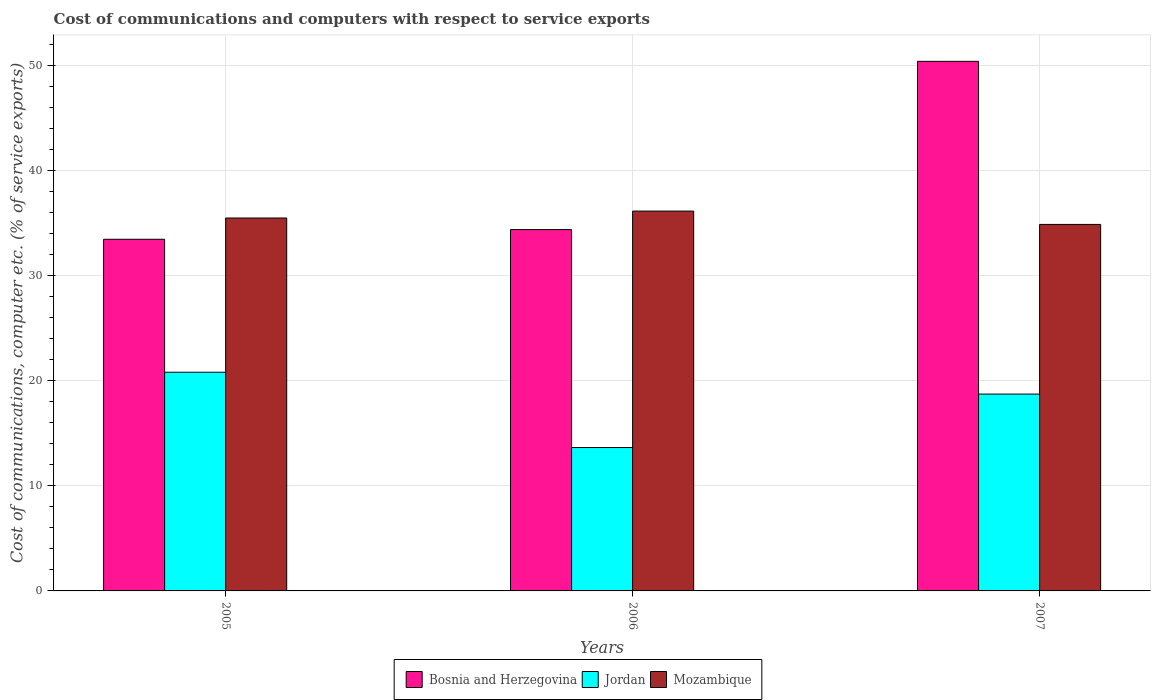How many different coloured bars are there?
Provide a succinct answer. 3. Are the number of bars per tick equal to the number of legend labels?
Provide a succinct answer. Yes. What is the label of the 2nd group of bars from the left?
Your response must be concise. 2006. What is the cost of communications and computers in Bosnia and Herzegovina in 2007?
Offer a very short reply. 50.39. Across all years, what is the maximum cost of communications and computers in Bosnia and Herzegovina?
Offer a very short reply. 50.39. Across all years, what is the minimum cost of communications and computers in Jordan?
Offer a terse response. 13.64. In which year was the cost of communications and computers in Jordan maximum?
Give a very brief answer. 2005. What is the total cost of communications and computers in Mozambique in the graph?
Offer a terse response. 106.5. What is the difference between the cost of communications and computers in Jordan in 2006 and that in 2007?
Keep it short and to the point. -5.09. What is the difference between the cost of communications and computers in Mozambique in 2007 and the cost of communications and computers in Bosnia and Herzegovina in 2006?
Your response must be concise. 0.49. What is the average cost of communications and computers in Bosnia and Herzegovina per year?
Your answer should be very brief. 39.41. In the year 2005, what is the difference between the cost of communications and computers in Mozambique and cost of communications and computers in Jordan?
Make the answer very short. 14.68. What is the ratio of the cost of communications and computers in Mozambique in 2005 to that in 2007?
Your answer should be compact. 1.02. Is the difference between the cost of communications and computers in Mozambique in 2005 and 2006 greater than the difference between the cost of communications and computers in Jordan in 2005 and 2006?
Your answer should be very brief. No. What is the difference between the highest and the second highest cost of communications and computers in Bosnia and Herzegovina?
Provide a short and direct response. 16.01. What is the difference between the highest and the lowest cost of communications and computers in Bosnia and Herzegovina?
Make the answer very short. 16.93. In how many years, is the cost of communications and computers in Mozambique greater than the average cost of communications and computers in Mozambique taken over all years?
Offer a terse response. 1. What does the 3rd bar from the left in 2006 represents?
Your answer should be compact. Mozambique. What does the 3rd bar from the right in 2006 represents?
Your answer should be compact. Bosnia and Herzegovina. Are all the bars in the graph horizontal?
Your answer should be very brief. No. How many years are there in the graph?
Your answer should be compact. 3. Are the values on the major ticks of Y-axis written in scientific E-notation?
Your answer should be compact. No. Does the graph contain any zero values?
Offer a very short reply. No. Does the graph contain grids?
Make the answer very short. Yes. How many legend labels are there?
Provide a succinct answer. 3. What is the title of the graph?
Your response must be concise. Cost of communications and computers with respect to service exports. Does "Namibia" appear as one of the legend labels in the graph?
Offer a very short reply. No. What is the label or title of the Y-axis?
Keep it short and to the point. Cost of communications, computer etc. (% of service exports). What is the Cost of communications, computer etc. (% of service exports) of Bosnia and Herzegovina in 2005?
Ensure brevity in your answer.  33.46. What is the Cost of communications, computer etc. (% of service exports) in Jordan in 2005?
Your response must be concise. 20.81. What is the Cost of communications, computer etc. (% of service exports) in Mozambique in 2005?
Keep it short and to the point. 35.48. What is the Cost of communications, computer etc. (% of service exports) of Bosnia and Herzegovina in 2006?
Your answer should be compact. 34.38. What is the Cost of communications, computer etc. (% of service exports) in Jordan in 2006?
Make the answer very short. 13.64. What is the Cost of communications, computer etc. (% of service exports) in Mozambique in 2006?
Your response must be concise. 36.14. What is the Cost of communications, computer etc. (% of service exports) in Bosnia and Herzegovina in 2007?
Provide a succinct answer. 50.39. What is the Cost of communications, computer etc. (% of service exports) in Jordan in 2007?
Offer a terse response. 18.73. What is the Cost of communications, computer etc. (% of service exports) of Mozambique in 2007?
Offer a very short reply. 34.87. Across all years, what is the maximum Cost of communications, computer etc. (% of service exports) of Bosnia and Herzegovina?
Provide a succinct answer. 50.39. Across all years, what is the maximum Cost of communications, computer etc. (% of service exports) in Jordan?
Your answer should be compact. 20.81. Across all years, what is the maximum Cost of communications, computer etc. (% of service exports) of Mozambique?
Keep it short and to the point. 36.14. Across all years, what is the minimum Cost of communications, computer etc. (% of service exports) in Bosnia and Herzegovina?
Ensure brevity in your answer.  33.46. Across all years, what is the minimum Cost of communications, computer etc. (% of service exports) in Jordan?
Ensure brevity in your answer.  13.64. Across all years, what is the minimum Cost of communications, computer etc. (% of service exports) in Mozambique?
Provide a short and direct response. 34.87. What is the total Cost of communications, computer etc. (% of service exports) in Bosnia and Herzegovina in the graph?
Provide a succinct answer. 118.23. What is the total Cost of communications, computer etc. (% of service exports) in Jordan in the graph?
Provide a short and direct response. 53.18. What is the total Cost of communications, computer etc. (% of service exports) in Mozambique in the graph?
Your answer should be compact. 106.5. What is the difference between the Cost of communications, computer etc. (% of service exports) of Bosnia and Herzegovina in 2005 and that in 2006?
Make the answer very short. -0.92. What is the difference between the Cost of communications, computer etc. (% of service exports) of Jordan in 2005 and that in 2006?
Keep it short and to the point. 7.16. What is the difference between the Cost of communications, computer etc. (% of service exports) in Mozambique in 2005 and that in 2006?
Provide a short and direct response. -0.66. What is the difference between the Cost of communications, computer etc. (% of service exports) of Bosnia and Herzegovina in 2005 and that in 2007?
Provide a succinct answer. -16.93. What is the difference between the Cost of communications, computer etc. (% of service exports) in Jordan in 2005 and that in 2007?
Provide a succinct answer. 2.08. What is the difference between the Cost of communications, computer etc. (% of service exports) of Mozambique in 2005 and that in 2007?
Keep it short and to the point. 0.61. What is the difference between the Cost of communications, computer etc. (% of service exports) in Bosnia and Herzegovina in 2006 and that in 2007?
Offer a terse response. -16.01. What is the difference between the Cost of communications, computer etc. (% of service exports) of Jordan in 2006 and that in 2007?
Keep it short and to the point. -5.09. What is the difference between the Cost of communications, computer etc. (% of service exports) of Mozambique in 2006 and that in 2007?
Keep it short and to the point. 1.27. What is the difference between the Cost of communications, computer etc. (% of service exports) of Bosnia and Herzegovina in 2005 and the Cost of communications, computer etc. (% of service exports) of Jordan in 2006?
Provide a succinct answer. 19.82. What is the difference between the Cost of communications, computer etc. (% of service exports) in Bosnia and Herzegovina in 2005 and the Cost of communications, computer etc. (% of service exports) in Mozambique in 2006?
Keep it short and to the point. -2.68. What is the difference between the Cost of communications, computer etc. (% of service exports) in Jordan in 2005 and the Cost of communications, computer etc. (% of service exports) in Mozambique in 2006?
Make the answer very short. -15.34. What is the difference between the Cost of communications, computer etc. (% of service exports) of Bosnia and Herzegovina in 2005 and the Cost of communications, computer etc. (% of service exports) of Jordan in 2007?
Keep it short and to the point. 14.73. What is the difference between the Cost of communications, computer etc. (% of service exports) of Bosnia and Herzegovina in 2005 and the Cost of communications, computer etc. (% of service exports) of Mozambique in 2007?
Provide a succinct answer. -1.41. What is the difference between the Cost of communications, computer etc. (% of service exports) in Jordan in 2005 and the Cost of communications, computer etc. (% of service exports) in Mozambique in 2007?
Offer a terse response. -14.07. What is the difference between the Cost of communications, computer etc. (% of service exports) of Bosnia and Herzegovina in 2006 and the Cost of communications, computer etc. (% of service exports) of Jordan in 2007?
Ensure brevity in your answer.  15.66. What is the difference between the Cost of communications, computer etc. (% of service exports) of Bosnia and Herzegovina in 2006 and the Cost of communications, computer etc. (% of service exports) of Mozambique in 2007?
Provide a short and direct response. -0.49. What is the difference between the Cost of communications, computer etc. (% of service exports) in Jordan in 2006 and the Cost of communications, computer etc. (% of service exports) in Mozambique in 2007?
Keep it short and to the point. -21.23. What is the average Cost of communications, computer etc. (% of service exports) in Bosnia and Herzegovina per year?
Offer a very short reply. 39.41. What is the average Cost of communications, computer etc. (% of service exports) of Jordan per year?
Make the answer very short. 17.73. What is the average Cost of communications, computer etc. (% of service exports) in Mozambique per year?
Give a very brief answer. 35.5. In the year 2005, what is the difference between the Cost of communications, computer etc. (% of service exports) in Bosnia and Herzegovina and Cost of communications, computer etc. (% of service exports) in Jordan?
Your answer should be compact. 12.65. In the year 2005, what is the difference between the Cost of communications, computer etc. (% of service exports) of Bosnia and Herzegovina and Cost of communications, computer etc. (% of service exports) of Mozambique?
Ensure brevity in your answer.  -2.02. In the year 2005, what is the difference between the Cost of communications, computer etc. (% of service exports) of Jordan and Cost of communications, computer etc. (% of service exports) of Mozambique?
Ensure brevity in your answer.  -14.68. In the year 2006, what is the difference between the Cost of communications, computer etc. (% of service exports) in Bosnia and Herzegovina and Cost of communications, computer etc. (% of service exports) in Jordan?
Ensure brevity in your answer.  20.74. In the year 2006, what is the difference between the Cost of communications, computer etc. (% of service exports) of Bosnia and Herzegovina and Cost of communications, computer etc. (% of service exports) of Mozambique?
Make the answer very short. -1.76. In the year 2006, what is the difference between the Cost of communications, computer etc. (% of service exports) in Jordan and Cost of communications, computer etc. (% of service exports) in Mozambique?
Give a very brief answer. -22.5. In the year 2007, what is the difference between the Cost of communications, computer etc. (% of service exports) in Bosnia and Herzegovina and Cost of communications, computer etc. (% of service exports) in Jordan?
Your answer should be very brief. 31.66. In the year 2007, what is the difference between the Cost of communications, computer etc. (% of service exports) in Bosnia and Herzegovina and Cost of communications, computer etc. (% of service exports) in Mozambique?
Provide a short and direct response. 15.52. In the year 2007, what is the difference between the Cost of communications, computer etc. (% of service exports) of Jordan and Cost of communications, computer etc. (% of service exports) of Mozambique?
Offer a very short reply. -16.14. What is the ratio of the Cost of communications, computer etc. (% of service exports) of Bosnia and Herzegovina in 2005 to that in 2006?
Offer a very short reply. 0.97. What is the ratio of the Cost of communications, computer etc. (% of service exports) in Jordan in 2005 to that in 2006?
Keep it short and to the point. 1.53. What is the ratio of the Cost of communications, computer etc. (% of service exports) of Mozambique in 2005 to that in 2006?
Keep it short and to the point. 0.98. What is the ratio of the Cost of communications, computer etc. (% of service exports) of Bosnia and Herzegovina in 2005 to that in 2007?
Your response must be concise. 0.66. What is the ratio of the Cost of communications, computer etc. (% of service exports) in Jordan in 2005 to that in 2007?
Make the answer very short. 1.11. What is the ratio of the Cost of communications, computer etc. (% of service exports) in Mozambique in 2005 to that in 2007?
Your answer should be very brief. 1.02. What is the ratio of the Cost of communications, computer etc. (% of service exports) in Bosnia and Herzegovina in 2006 to that in 2007?
Your answer should be very brief. 0.68. What is the ratio of the Cost of communications, computer etc. (% of service exports) in Jordan in 2006 to that in 2007?
Provide a succinct answer. 0.73. What is the ratio of the Cost of communications, computer etc. (% of service exports) of Mozambique in 2006 to that in 2007?
Give a very brief answer. 1.04. What is the difference between the highest and the second highest Cost of communications, computer etc. (% of service exports) of Bosnia and Herzegovina?
Offer a terse response. 16.01. What is the difference between the highest and the second highest Cost of communications, computer etc. (% of service exports) of Jordan?
Ensure brevity in your answer.  2.08. What is the difference between the highest and the second highest Cost of communications, computer etc. (% of service exports) of Mozambique?
Ensure brevity in your answer.  0.66. What is the difference between the highest and the lowest Cost of communications, computer etc. (% of service exports) of Bosnia and Herzegovina?
Your answer should be very brief. 16.93. What is the difference between the highest and the lowest Cost of communications, computer etc. (% of service exports) of Jordan?
Your answer should be compact. 7.16. What is the difference between the highest and the lowest Cost of communications, computer etc. (% of service exports) of Mozambique?
Make the answer very short. 1.27. 